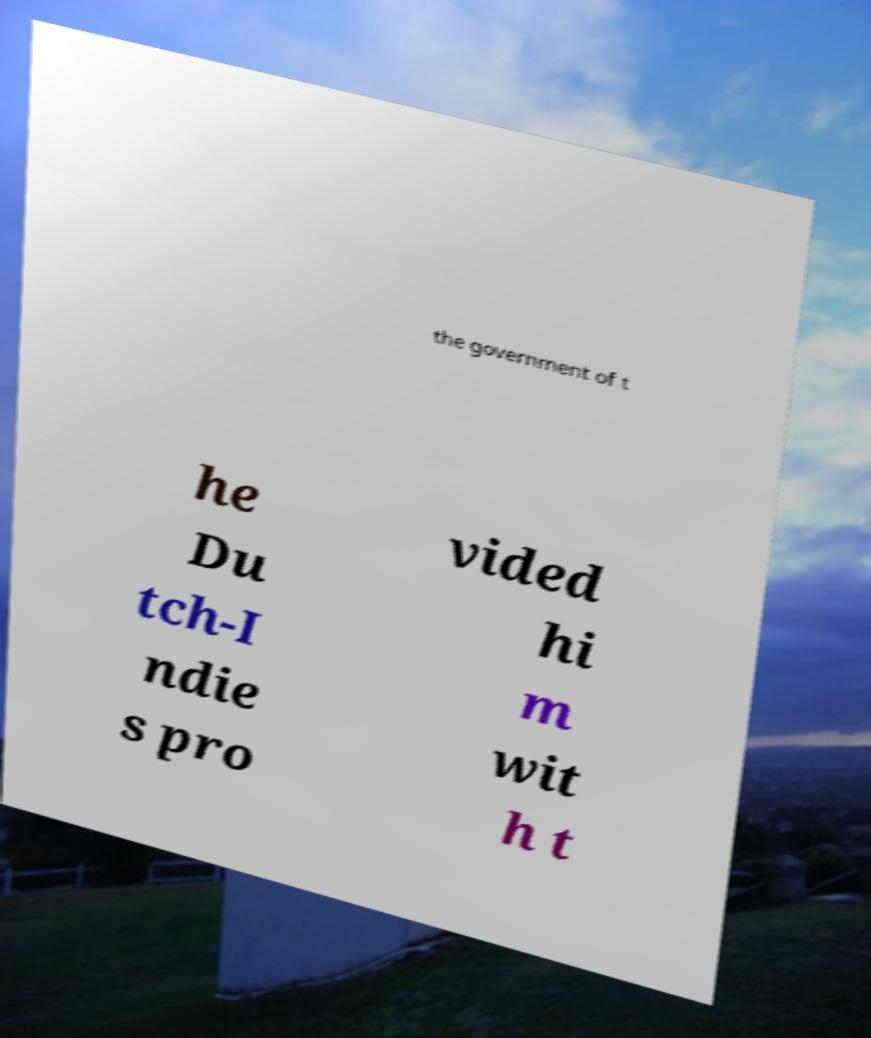Could you extract and type out the text from this image? the government of t he Du tch-I ndie s pro vided hi m wit h t 